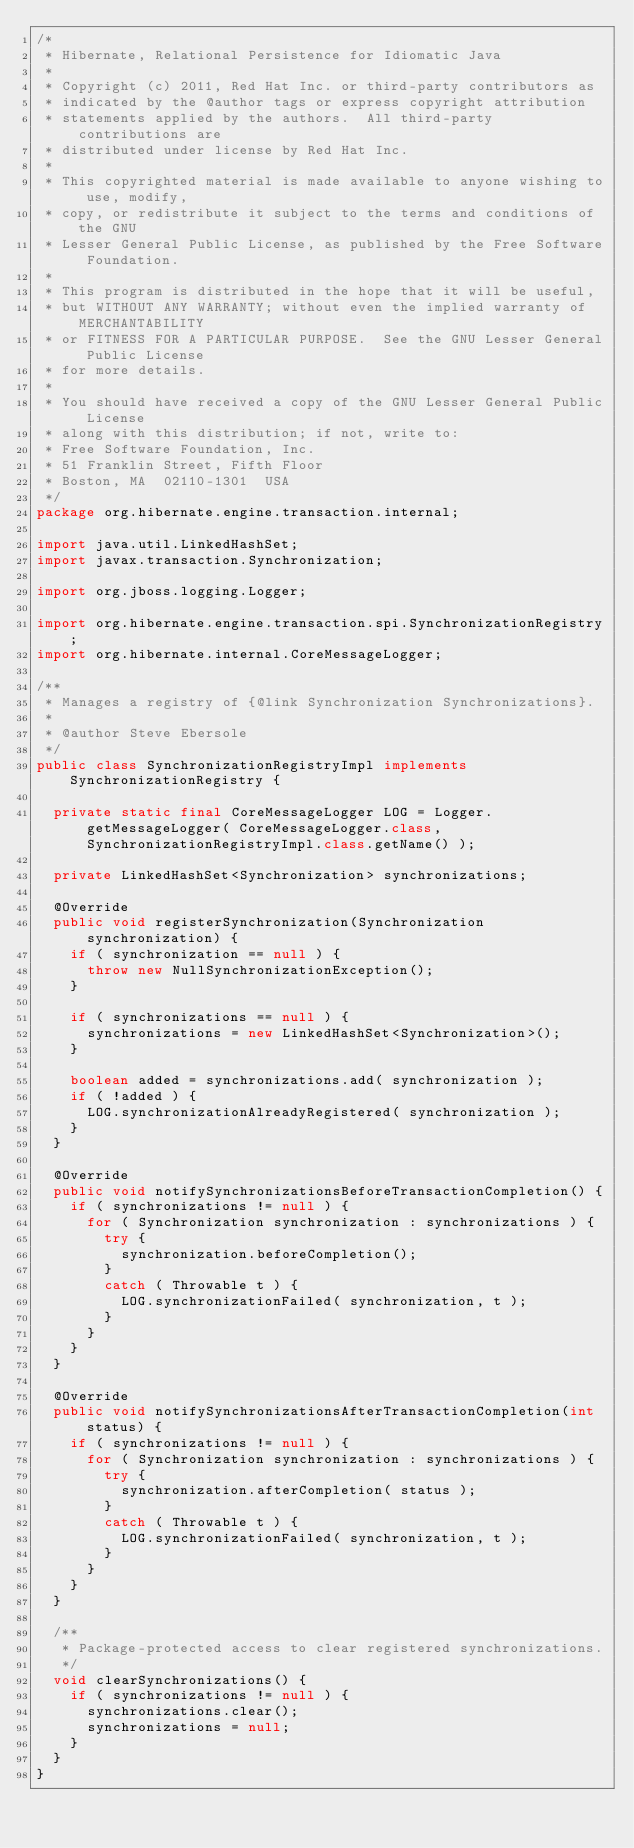<code> <loc_0><loc_0><loc_500><loc_500><_Java_>/*
 * Hibernate, Relational Persistence for Idiomatic Java
 *
 * Copyright (c) 2011, Red Hat Inc. or third-party contributors as
 * indicated by the @author tags or express copyright attribution
 * statements applied by the authors.  All third-party contributions are
 * distributed under license by Red Hat Inc.
 *
 * This copyrighted material is made available to anyone wishing to use, modify,
 * copy, or redistribute it subject to the terms and conditions of the GNU
 * Lesser General Public License, as published by the Free Software Foundation.
 *
 * This program is distributed in the hope that it will be useful,
 * but WITHOUT ANY WARRANTY; without even the implied warranty of MERCHANTABILITY
 * or FITNESS FOR A PARTICULAR PURPOSE.  See the GNU Lesser General Public License
 * for more details.
 *
 * You should have received a copy of the GNU Lesser General Public License
 * along with this distribution; if not, write to:
 * Free Software Foundation, Inc.
 * 51 Franklin Street, Fifth Floor
 * Boston, MA  02110-1301  USA
 */
package org.hibernate.engine.transaction.internal;

import java.util.LinkedHashSet;
import javax.transaction.Synchronization;

import org.jboss.logging.Logger;

import org.hibernate.engine.transaction.spi.SynchronizationRegistry;
import org.hibernate.internal.CoreMessageLogger;

/**
 * Manages a registry of {@link Synchronization Synchronizations}.
 *
 * @author Steve Ebersole
 */
public class SynchronizationRegistryImpl implements SynchronizationRegistry {

	private static final CoreMessageLogger LOG = Logger.getMessageLogger( CoreMessageLogger.class, SynchronizationRegistryImpl.class.getName() );

	private LinkedHashSet<Synchronization> synchronizations;

	@Override
	public void registerSynchronization(Synchronization synchronization) {
		if ( synchronization == null ) {
			throw new NullSynchronizationException();
		}

		if ( synchronizations == null ) {
			synchronizations = new LinkedHashSet<Synchronization>();
		}

		boolean added = synchronizations.add( synchronization );
		if ( !added ) {
			LOG.synchronizationAlreadyRegistered( synchronization );
		}
	}

	@Override
	public void notifySynchronizationsBeforeTransactionCompletion() {
		if ( synchronizations != null ) {
			for ( Synchronization synchronization : synchronizations ) {
				try {
					synchronization.beforeCompletion();
				}
				catch ( Throwable t ) {
					LOG.synchronizationFailed( synchronization, t );
				}
			}
		}
	}

	@Override
	public void notifySynchronizationsAfterTransactionCompletion(int status) {
		if ( synchronizations != null ) {
			for ( Synchronization synchronization : synchronizations ) {
				try {
					synchronization.afterCompletion( status );
				}
				catch ( Throwable t ) {
					LOG.synchronizationFailed( synchronization, t );
				}
			}
		}
	}

	/**
	 * Package-protected access to clear registered synchronizations.
	 */
	void clearSynchronizations() {
		if ( synchronizations != null ) {
			synchronizations.clear();
			synchronizations = null;
		}
	}
}
</code> 